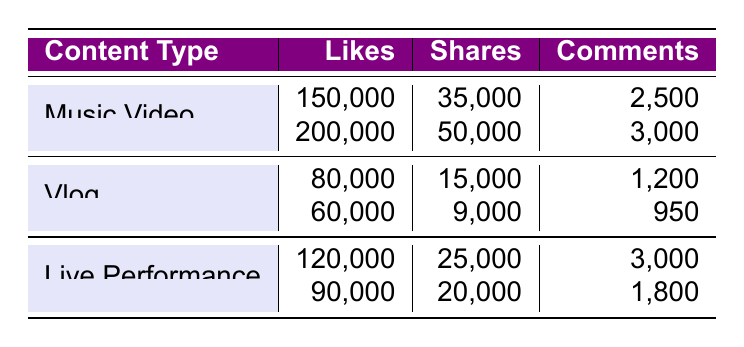What is the highest number of likes received by a music video? The table indicates that the music video "Crystallize" received 200,000 likes, which is the highest among all entries in the music video category.
Answer: 200,000 Which content type has the lowest number of comments? By reviewing the comments across all content types, the vlog titled "My Journey as a Violinist" has the lowest number of comments at 950.
Answer: 950 What is the total number of shares for live performances? The total shares for live performances can be calculated by adding the shares for the two entries: 25,000 (Radio City Music Hall) + 20,000 (Electric Forest Festival) = 45,000 shares.
Answer: 45,000 Do all music videos have more likes than vlogs? When comparing the likes: "Shatter Me" has 150,000, "Crystallize" has 200,000, while the vlogs have 80,000 and 60,000 respectively. Both music videos have more likes than both vlogs, so the statement is true.
Answer: Yes What is the average number of comments for all content types combined? To find the average, first, we sum the comments: 2,500 (Music Video 1) + 3,000 (Music Video 2) + 1,200 (Vlog 1) + 950 (Vlog 2) + 3,000 (Live Performance 1) + 1,800 (Live Performance 2) = 12,450 comments. Then divide by the total number of entries (6): 12,450 / 6 = 2,075.
Answer: 2,075 Which content type has the highest average likes? For music videos, the average likes are (150,000 + 200,000) / 2 = 175,000; for vlogs, it’s (80,000 + 60,000) / 2 = 70,000; for live performances, it’s (120,000 + 90,000) / 2 = 105,000. The highest average likes among content types is 175,000 for music videos.
Answer: Music Video Which post title in the vlog category received the most likes? In the vlog category, "Behind the Scenes of Live Performances" received 80,000 likes, which is higher than "My Journey as a Violinist" which received 60,000 likes.
Answer: Behind the Scenes of Live Performances Are there any content types that received more shares than likes? By analyzing the shares and likes: all content types have more likes than shares. Therefore, there are no content types with more shares than likes.
Answer: No What is the total number of likes across all content types? To find the total likes, we add: 150,000 + 200,000 + 80,000 + 60,000 + 120,000 + 90,000 = 700,000 likes in total across all entries.
Answer: 700,000 